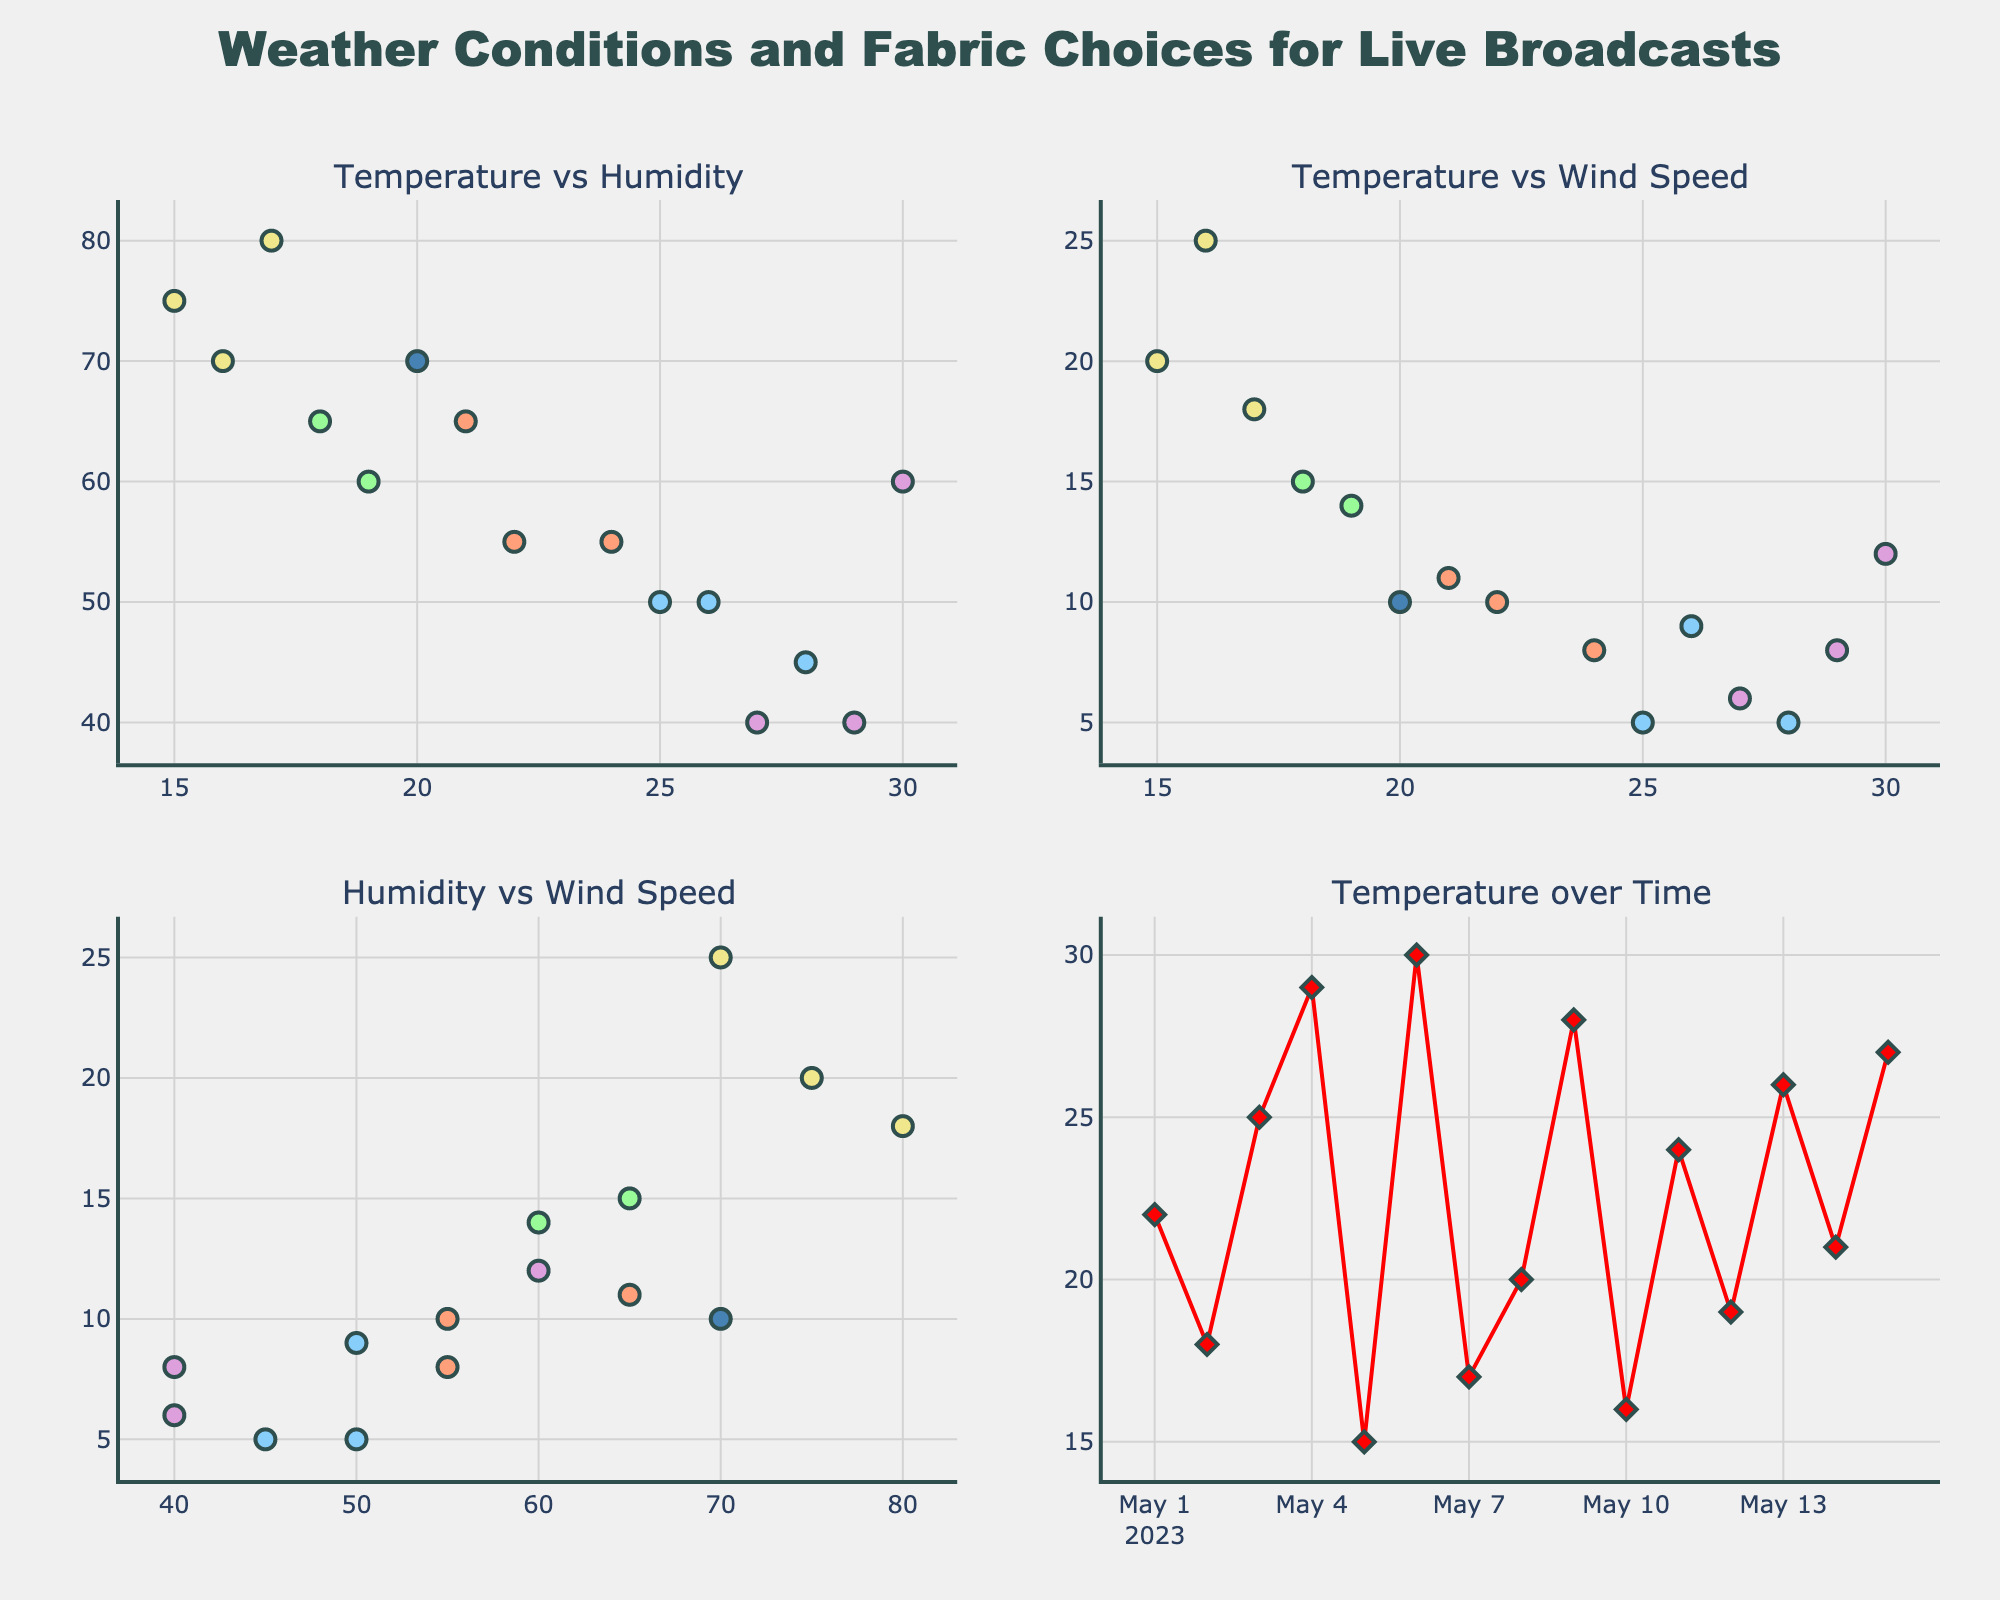What is the title of the figure? The title of the figure is clearly displayed at the top center of the plot. It reads "Weather Conditions and Fabric Choices for Live Broadcasts".
Answer: Weather Conditions and Fabric Choices for Live Broadcasts How many subplots are there in this figure? The figure shows a grid with four distinct plots. There are two rows and two columns, making it a total of four subplots.
Answer: Four Which fabric appears most frequently in the Temperature over Time plot? By examining the fabric names shown along with temperature data over dates, the fabric "Wool" appears multiple times indicating it is frequently used.
Answer: Wool What is the relationship between temperature and humidity? In the "Temperature vs Humidity" subplot, by looking at the spread of data points, most of the points seem to show no clear correlation between temperature and humidity.
Answer: No clear correlation Which fabric is associated with the highest temperatures? In the "Temperature vs Wind Speed" subplot, the highest temperatures are marked with specific fabric colors. The highest temperature points are associated with "Synthetic" fabric.
Answer: Synthetic Is there any visible trend in the Temperature over Time plot? The "Temperature over Time" subplot shows the temperature data as a series of points connected by lines. There is an upward and downward fluctuation but no strong increasing or decreasing trend over the given dates.
Answer: No strong trend What colors represent the "Denim" and "Silk" fabrics in the plots? In the scatter plots, the colors associated with fabrics are indicated in the fabric legend. "Denim" is shown in blue and "Silk" in light blue.
Answer: Denim is blue, Silk is light blue Are higher wind speeds associated with certain fabrics? By looking at the "Temperature vs Wind Speed" and "Humidity vs Wind Speed" subplots, higher wind speeds seem to align more frequently with fabrics such as "Wool".
Answer: Wool In the "Humidity vs Wind Speed" subplot, which point corresponds to the highest humidity observed? The highest humidity in the "Humidity vs Wind Speed" subplot is 80%. The marker at this point signifies "Wool" fabric.
Answer: Wool What is the color used for the "Linen" fabric? Referring to the fabric legend in the plot, the color for "Linen" is a light green shade.
Answer: Light green 